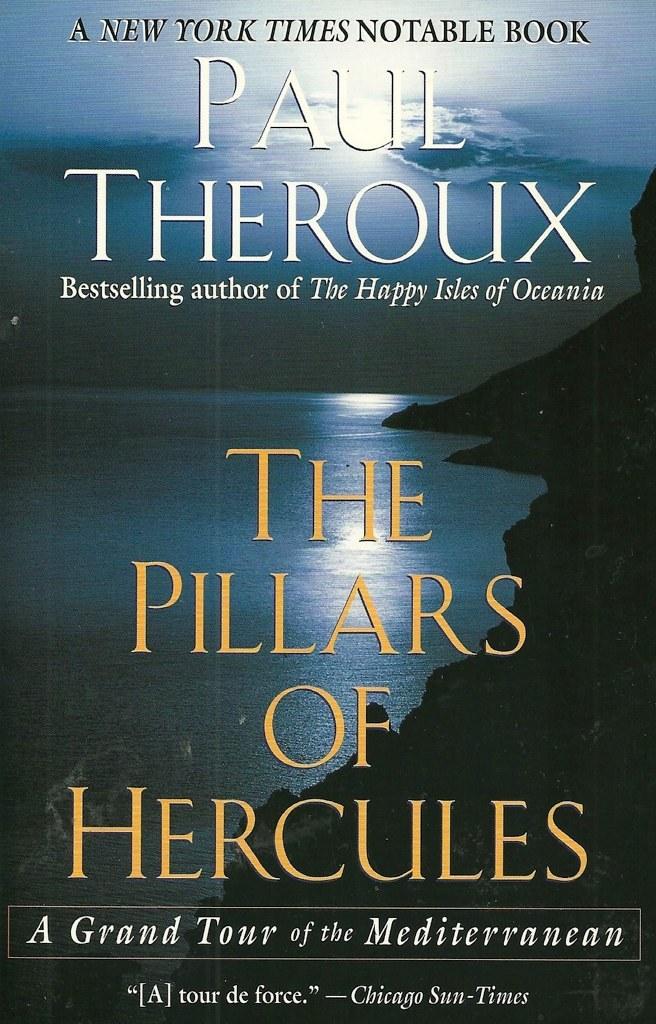What is the title of the book?
Keep it short and to the point. The pillars of hercules. Who wrote this book?
Give a very brief answer. Paul theroux. 